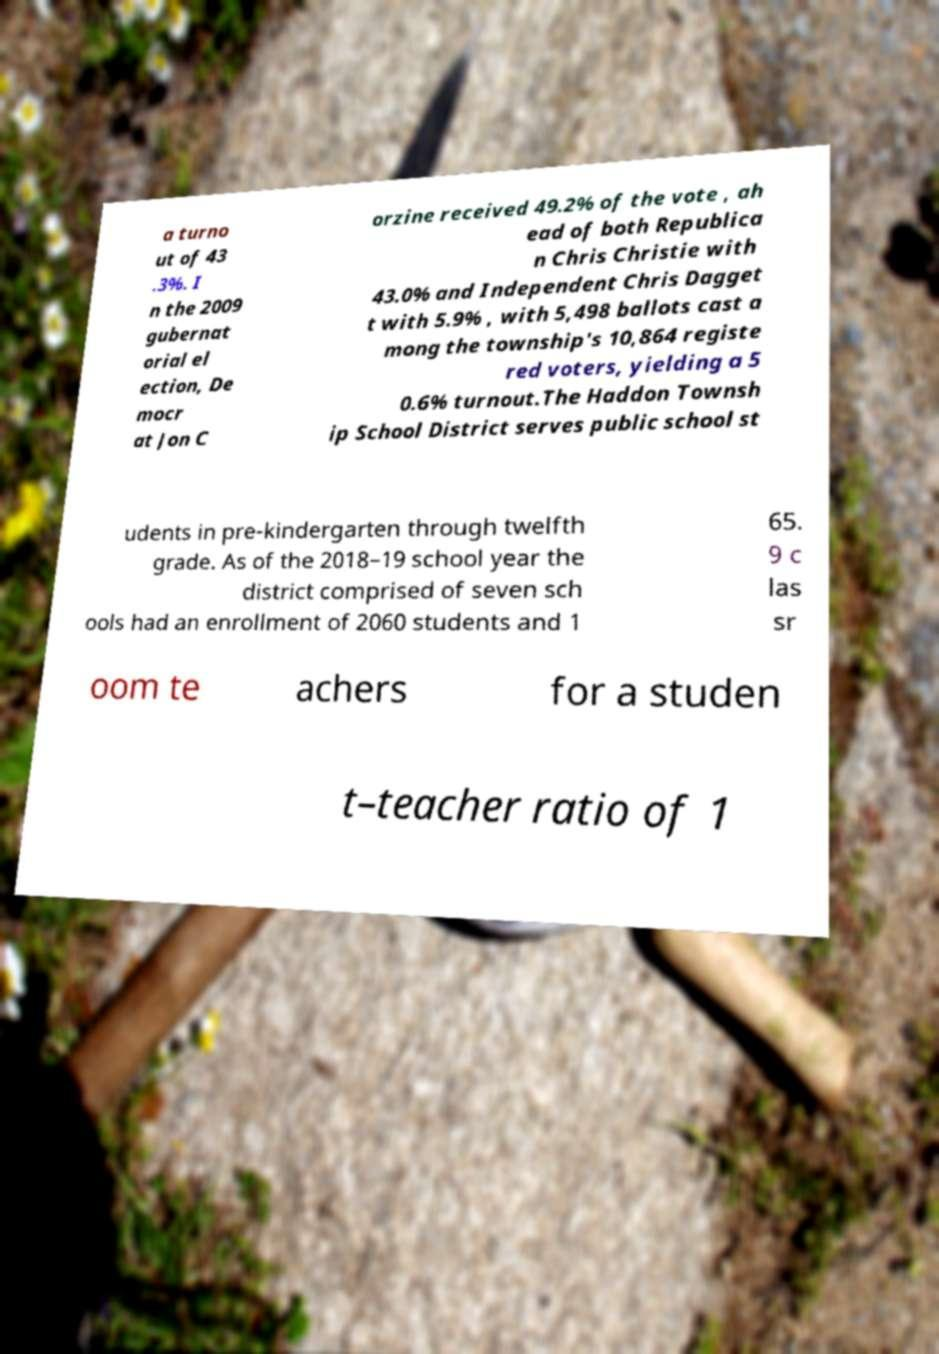I need the written content from this picture converted into text. Can you do that? a turno ut of 43 .3%. I n the 2009 gubernat orial el ection, De mocr at Jon C orzine received 49.2% of the vote , ah ead of both Republica n Chris Christie with 43.0% and Independent Chris Dagget t with 5.9% , with 5,498 ballots cast a mong the township's 10,864 registe red voters, yielding a 5 0.6% turnout.The Haddon Townsh ip School District serves public school st udents in pre-kindergarten through twelfth grade. As of the 2018–19 school year the district comprised of seven sch ools had an enrollment of 2060 students and 1 65. 9 c las sr oom te achers for a studen t–teacher ratio of 1 